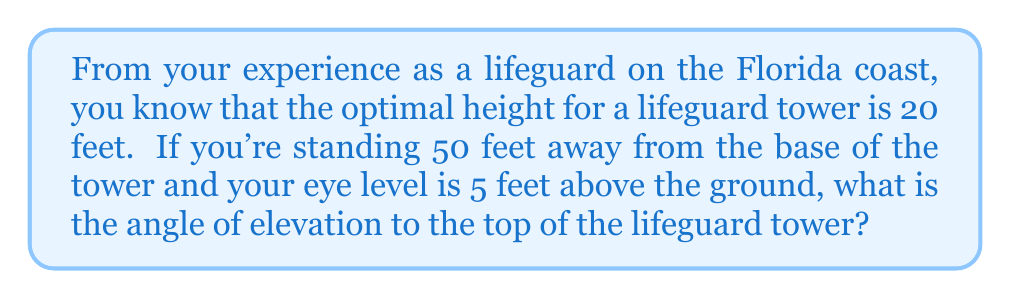Provide a solution to this math problem. Let's approach this step-by-step:

1) First, let's visualize the problem:

[asy]
import geometry;

pair A = (0,0), B = (50,0), C = (50,5), D = (0,20);
draw(A--B--D--A);
draw(B--C);
draw(C--D,dashed);

label("Ground", (25,0), S);
label("50 ft", (25,0), N);
label("20 ft", (0,10), W);
label("5 ft", (50,2.5), E);
label("θ", (50,5), NW);

dot("A", A, SW);
dot("B", B, SE);
dot("C", C, E);
dot("D", D, NW);
[/asy]

2) We need to find the angle θ at point C.

3) In the right triangle ACD:
   - The adjacent side (AB) is 50 feet
   - The opposite side (AD - AC) is (20 - 5) = 15 feet

4) We can use the tangent function to find the angle:

   $$\tan(\theta) = \frac{\text{opposite}}{\text{adjacent}} = \frac{15}{50}$$

5) To find θ, we need to use the inverse tangent (arctan or $\tan^{-1}$):

   $$\theta = \tan^{-1}\left(\frac{15}{50}\right)$$

6) Using a calculator or computer:

   $$\theta = \tan^{-1}(0.3) \approx 16.70^\circ$$

Therefore, the angle of elevation to the top of the lifeguard tower is approximately 16.70°.
Answer: $16.70^\circ$ 